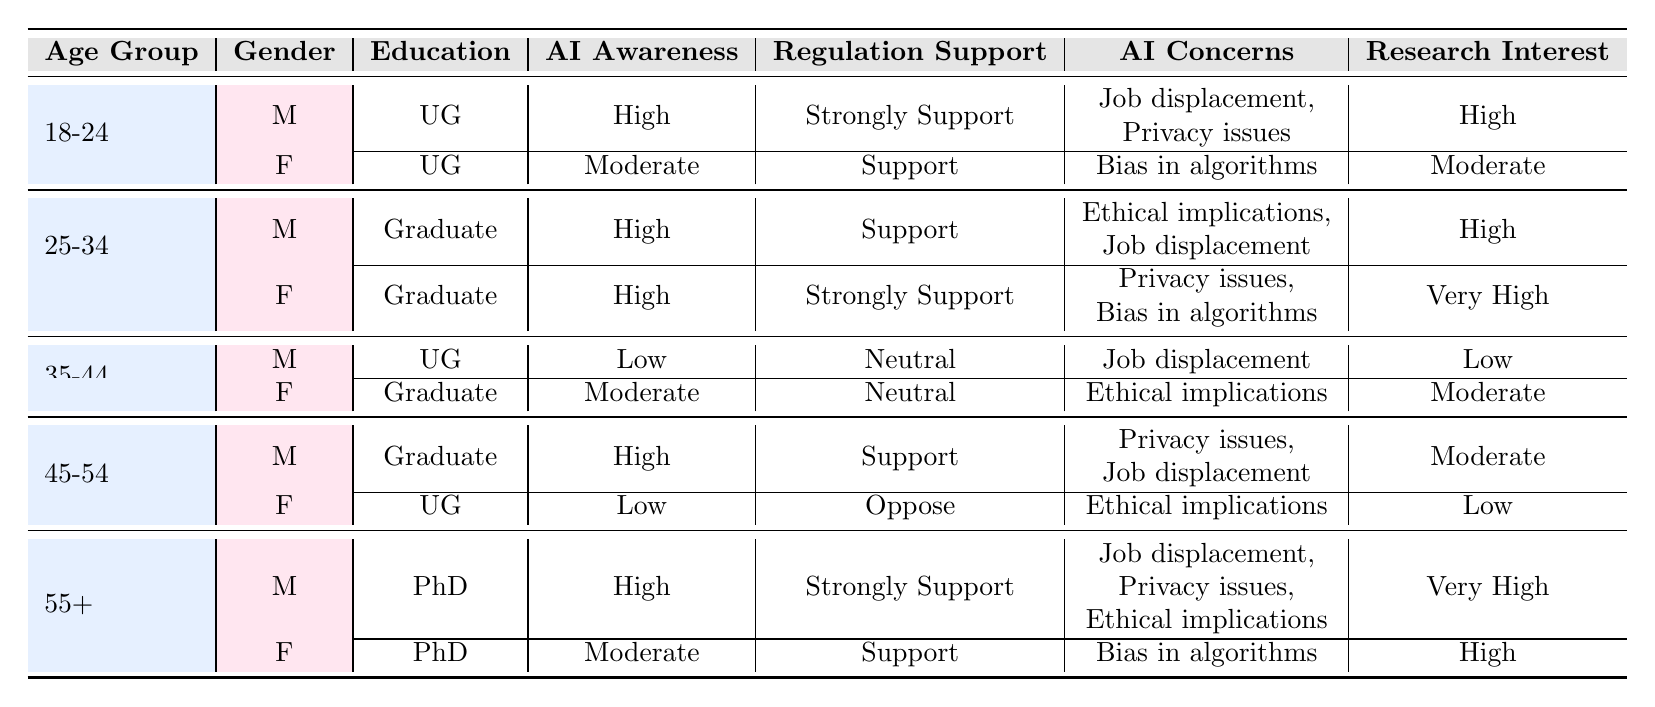What is the AI awareness level of females aged 35-44? Referring to the table, under the age group 35-44, the female respondent has an "awareness_of_ai" level of "Moderate."
Answer: Moderate What concerns about AI do males aged 55 and older have? The table shows that males aged 55+ are concerned about "Job displacement," "Privacy issues," and "Ethical implications."
Answer: Job displacement, Privacy issues, Ethical implications Do any respondents with a PhD support AI regulation? By looking at the table, both females and males with a PhD show "Strongly Support" and "Support" for regulation, respectively.
Answer: Yes Among all age groups, which gender has the lowest interest in AI research? The table indicates that females aged 45-54 have the "interest_in_ai_research" level labeled as "Low," which is the lowest indicated interest across all groups.
Answer: Female, 45-54 What is the average level of support for regulation among the age group 25-34? There are two respondents in the age group 25-34: one male supports regulation ("Support") and one female strongly supports it ("Strongly Support"). We can assign numerical values (Strongly Support=2, Support=1) and calculate: (1 + 2) / 2 = 1.5, which translates to an average level of support between the two responses.
Answer: 1.5 Do respondents with a graduate education generally have a higher support for regulation than those with an undergraduate education? Looking across the table, the respondents with graduate education have support ("Support" or "Strongly Support") while undergraduate educated individuals show a mix, including "Neutral" and "Oppose." Thus, graduates have generally higher support for regulation.
Answer: Yes What percentage of the respondents are "Strongly Support" AI regulation? There are 2 respondents who "Strongly Support" regulation out of a total of 10 individuals surveyed, so the calculation is (2/10) * 100 = 20%.
Answer: 20% What is the most common AI concern among respondents who "Oppose" regulation? The only respondent who "Oppose" regulation is a female aged 45-54, whose concern about AI is "Ethical implications," thus this is the most common concern among any respondents who oppose regulation, given there is only one such respondent.
Answer: Ethical implications Cross-reference support for regulation with AI awareness for males aged 25-34. What patterns do you see? The male respondent in this age group has "High" AI awareness and "Support" for regulation. This suggests a positive correlation: higher awareness often aligns with greater support for regulation in this specific demographic.
Answer: Higher awareness correlates with support 